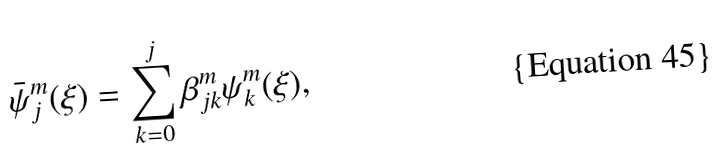Convert formula to latex. <formula><loc_0><loc_0><loc_500><loc_500>\bar { \psi } _ { j } ^ { m } ( \xi ) = \sum _ { k = 0 } ^ { j } \beta _ { j k } ^ { m } \psi _ { k } ^ { m } ( \xi ) ,</formula> 